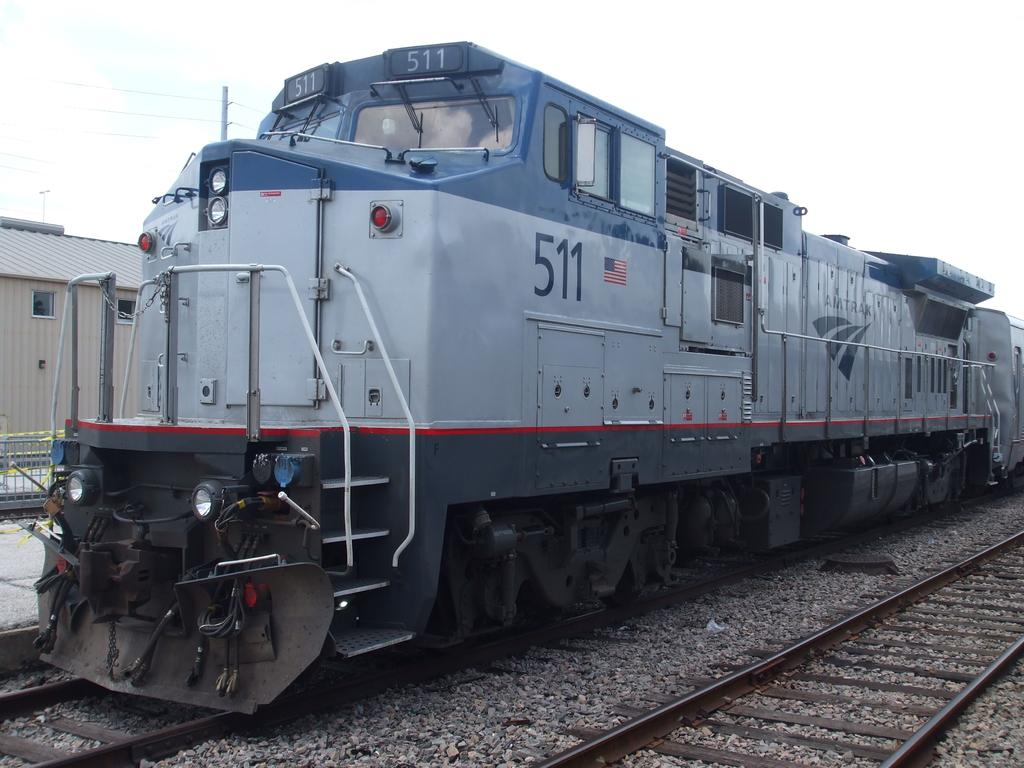What is the main subject of the picture? The main subject of the picture is a rail engine. Where is the rail engine located in the picture? The rail engine is in the middle of the picture. What is the rail engine positioned on? The rail engine is on a railway track. Can you describe the background of the picture? The sky is visible in the background of the picture. How many chickens can be seen kicking a soccer ball on the railway track in the image? There are no chickens or soccer balls present in the image; it features a rail engine on a railway track with another track on the right side and a visible sky in the background. 